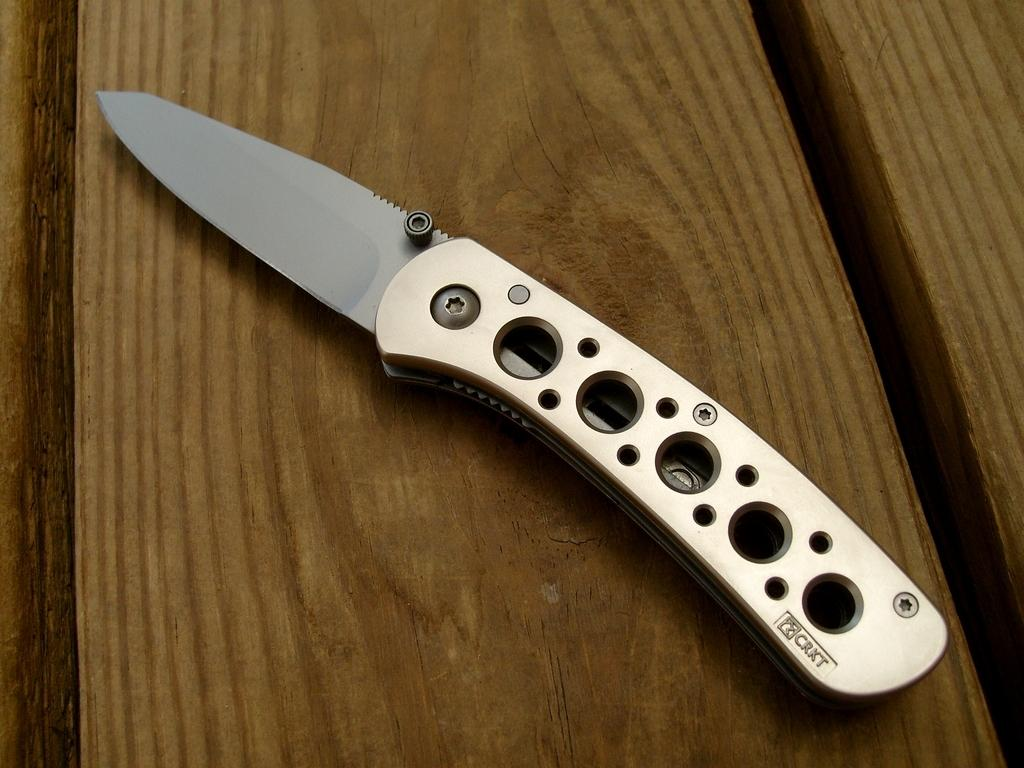What type of object is present on the wooden table in the image? There is a metal knife on the wooden table in the image. What material is the knife made of? The knife is made of metal. What is the surface on which the knife is placed? The knife is on a wooden table. How many roses are on the metal knife in the image? There are no roses present on the metal knife in the image. 